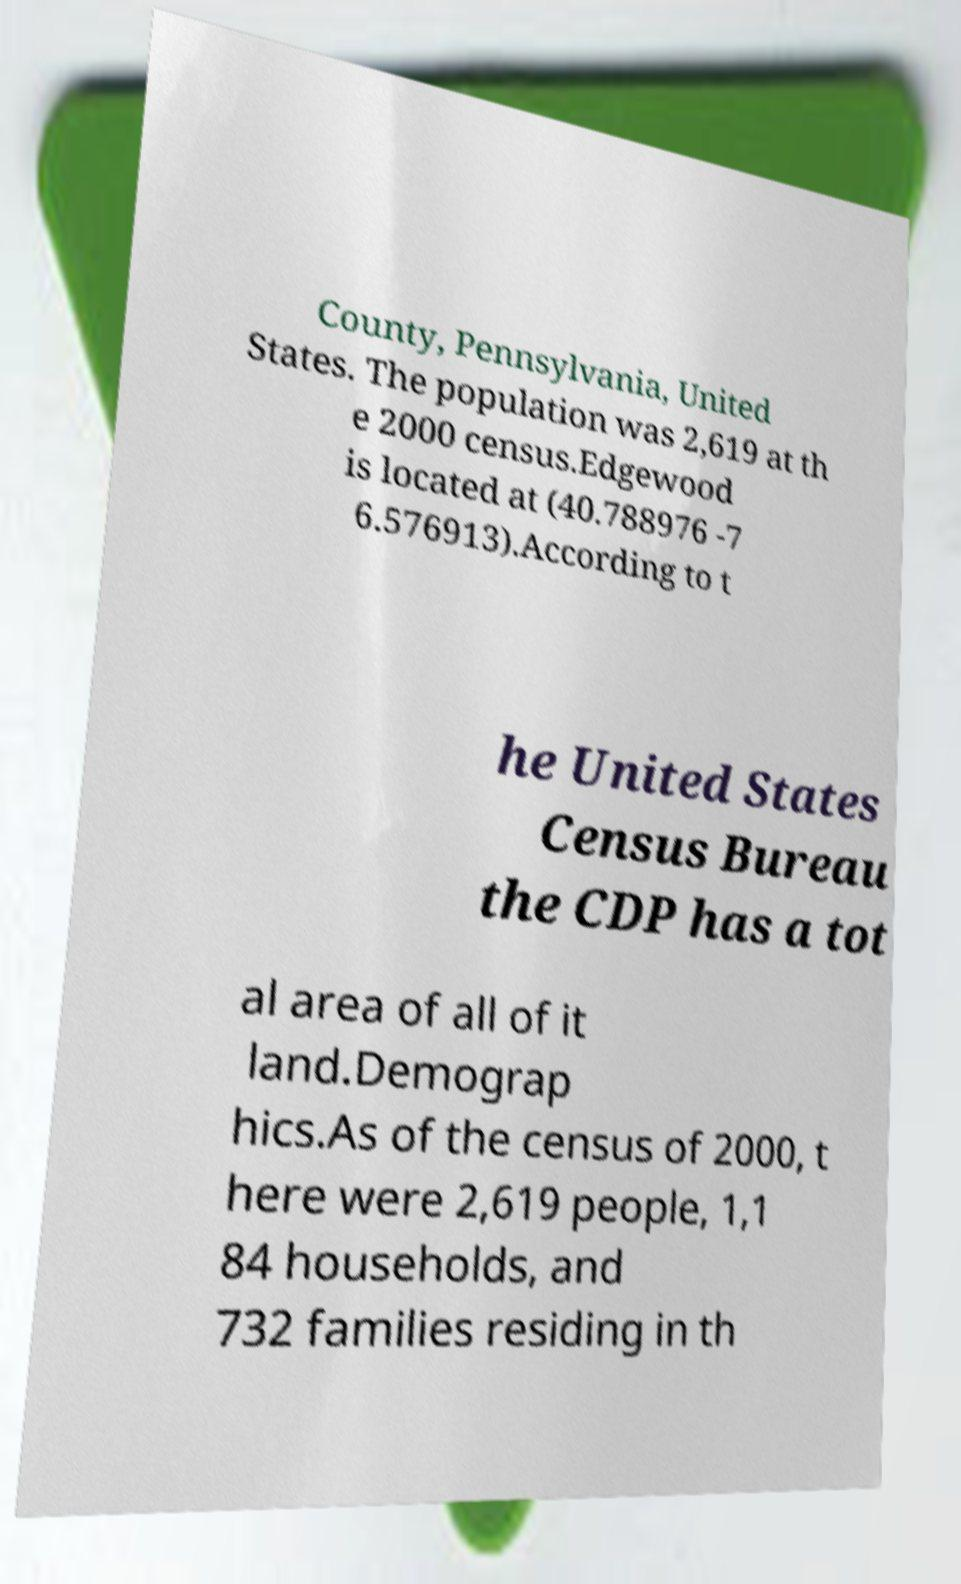There's text embedded in this image that I need extracted. Can you transcribe it verbatim? County, Pennsylvania, United States. The population was 2,619 at th e 2000 census.Edgewood is located at (40.788976 -7 6.576913).According to t he United States Census Bureau the CDP has a tot al area of all of it land.Demograp hics.As of the census of 2000, t here were 2,619 people, 1,1 84 households, and 732 families residing in th 